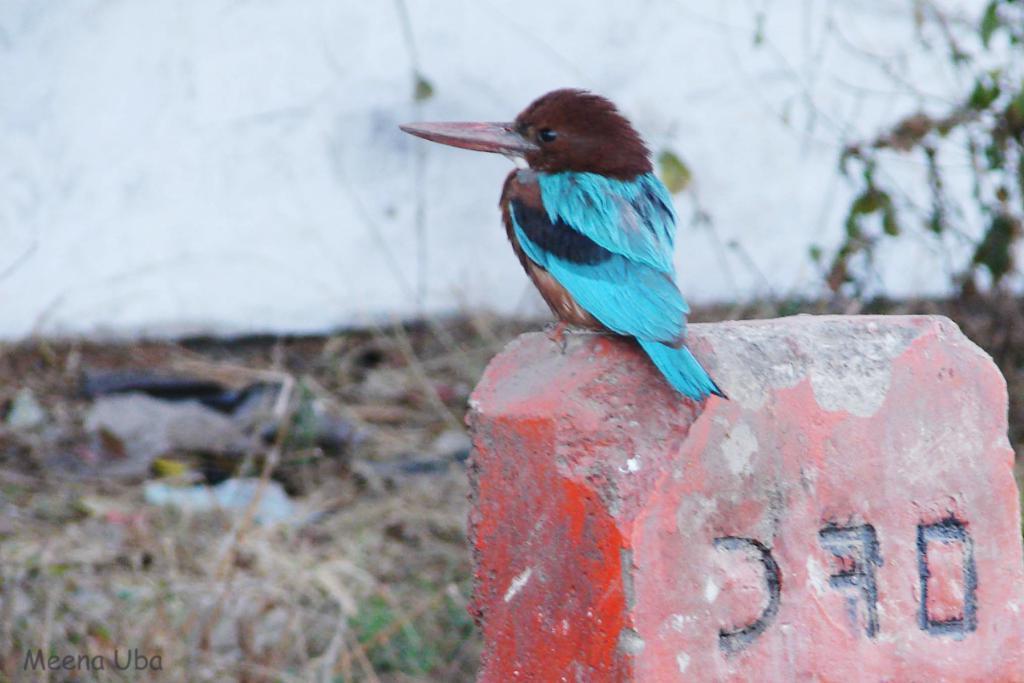How would you summarize this image in a sentence or two? In this picture, we see a bird with blue color is on the red color kilometer stone or a wall. It has a long beak. At the bottom of the picture, we see grass and twigs. In the background, we see a white wall. It is blurred in the background. 